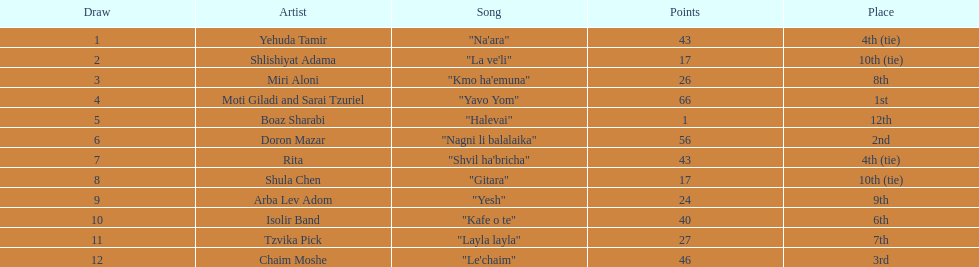Doron mazar, which artist(s) had the most points? Moti Giladi and Sarai Tzuriel. 